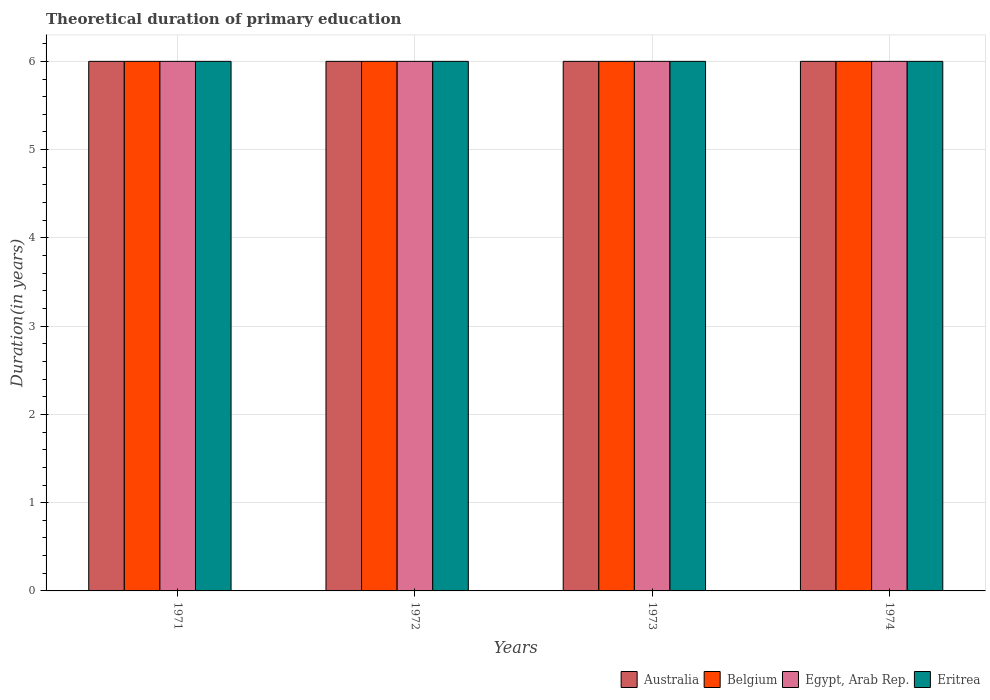Are the number of bars per tick equal to the number of legend labels?
Your answer should be compact. Yes. How many bars are there on the 1st tick from the left?
Offer a very short reply. 4. How many bars are there on the 4th tick from the right?
Keep it short and to the point. 4. In which year was the total theoretical duration of primary education in Belgium minimum?
Keep it short and to the point. 1971. What is the total total theoretical duration of primary education in Belgium in the graph?
Provide a short and direct response. 24. What is the difference between the total theoretical duration of primary education in Egypt, Arab Rep. in 1973 and the total theoretical duration of primary education in Eritrea in 1971?
Make the answer very short. 0. What is the average total theoretical duration of primary education in Eritrea per year?
Ensure brevity in your answer.  6. In the year 1972, what is the difference between the total theoretical duration of primary education in Eritrea and total theoretical duration of primary education in Belgium?
Ensure brevity in your answer.  0. Is the total theoretical duration of primary education in Egypt, Arab Rep. in 1971 less than that in 1972?
Provide a succinct answer. No. In how many years, is the total theoretical duration of primary education in Eritrea greater than the average total theoretical duration of primary education in Eritrea taken over all years?
Provide a short and direct response. 0. Is it the case that in every year, the sum of the total theoretical duration of primary education in Australia and total theoretical duration of primary education in Eritrea is greater than the sum of total theoretical duration of primary education in Egypt, Arab Rep. and total theoretical duration of primary education in Belgium?
Provide a succinct answer. No. What does the 4th bar from the left in 1973 represents?
Your response must be concise. Eritrea. What does the 2nd bar from the right in 1974 represents?
Your response must be concise. Egypt, Arab Rep. Is it the case that in every year, the sum of the total theoretical duration of primary education in Belgium and total theoretical duration of primary education in Eritrea is greater than the total theoretical duration of primary education in Australia?
Your response must be concise. Yes. What is the difference between two consecutive major ticks on the Y-axis?
Offer a terse response. 1. Does the graph contain any zero values?
Provide a succinct answer. No. How many legend labels are there?
Your response must be concise. 4. How are the legend labels stacked?
Your answer should be very brief. Horizontal. What is the title of the graph?
Ensure brevity in your answer.  Theoretical duration of primary education. Does "Macao" appear as one of the legend labels in the graph?
Make the answer very short. No. What is the label or title of the Y-axis?
Offer a terse response. Duration(in years). What is the Duration(in years) in Egypt, Arab Rep. in 1971?
Your answer should be compact. 6. What is the Duration(in years) of Eritrea in 1972?
Offer a terse response. 6. What is the Duration(in years) of Eritrea in 1973?
Keep it short and to the point. 6. What is the Duration(in years) of Australia in 1974?
Your answer should be compact. 6. What is the Duration(in years) of Belgium in 1974?
Give a very brief answer. 6. What is the Duration(in years) in Eritrea in 1974?
Ensure brevity in your answer.  6. Across all years, what is the maximum Duration(in years) of Australia?
Offer a very short reply. 6. Across all years, what is the maximum Duration(in years) in Belgium?
Make the answer very short. 6. Across all years, what is the maximum Duration(in years) of Eritrea?
Your response must be concise. 6. Across all years, what is the minimum Duration(in years) in Australia?
Your response must be concise. 6. Across all years, what is the minimum Duration(in years) of Belgium?
Provide a short and direct response. 6. Across all years, what is the minimum Duration(in years) of Eritrea?
Keep it short and to the point. 6. What is the total Duration(in years) in Australia in the graph?
Provide a short and direct response. 24. What is the difference between the Duration(in years) of Australia in 1971 and that in 1972?
Your answer should be very brief. 0. What is the difference between the Duration(in years) of Belgium in 1971 and that in 1972?
Provide a succinct answer. 0. What is the difference between the Duration(in years) of Eritrea in 1971 and that in 1972?
Offer a terse response. 0. What is the difference between the Duration(in years) of Australia in 1971 and that in 1973?
Offer a terse response. 0. What is the difference between the Duration(in years) in Egypt, Arab Rep. in 1971 and that in 1973?
Give a very brief answer. 0. What is the difference between the Duration(in years) in Australia in 1971 and that in 1974?
Your response must be concise. 0. What is the difference between the Duration(in years) in Australia in 1972 and that in 1973?
Give a very brief answer. 0. What is the difference between the Duration(in years) of Belgium in 1972 and that in 1974?
Offer a very short reply. 0. What is the difference between the Duration(in years) in Eritrea in 1972 and that in 1974?
Your answer should be very brief. 0. What is the difference between the Duration(in years) of Australia in 1973 and that in 1974?
Offer a terse response. 0. What is the difference between the Duration(in years) of Belgium in 1973 and that in 1974?
Ensure brevity in your answer.  0. What is the difference between the Duration(in years) of Australia in 1971 and the Duration(in years) of Eritrea in 1972?
Make the answer very short. 0. What is the difference between the Duration(in years) in Belgium in 1971 and the Duration(in years) in Egypt, Arab Rep. in 1972?
Offer a very short reply. 0. What is the difference between the Duration(in years) in Australia in 1971 and the Duration(in years) in Egypt, Arab Rep. in 1973?
Ensure brevity in your answer.  0. What is the difference between the Duration(in years) of Belgium in 1971 and the Duration(in years) of Eritrea in 1973?
Ensure brevity in your answer.  0. What is the difference between the Duration(in years) of Egypt, Arab Rep. in 1971 and the Duration(in years) of Eritrea in 1973?
Offer a very short reply. 0. What is the difference between the Duration(in years) in Australia in 1971 and the Duration(in years) in Belgium in 1974?
Keep it short and to the point. 0. What is the difference between the Duration(in years) of Egypt, Arab Rep. in 1971 and the Duration(in years) of Eritrea in 1974?
Ensure brevity in your answer.  0. What is the difference between the Duration(in years) of Australia in 1972 and the Duration(in years) of Belgium in 1973?
Give a very brief answer. 0. What is the difference between the Duration(in years) of Australia in 1972 and the Duration(in years) of Eritrea in 1973?
Provide a succinct answer. 0. What is the difference between the Duration(in years) in Belgium in 1972 and the Duration(in years) in Egypt, Arab Rep. in 1973?
Make the answer very short. 0. What is the difference between the Duration(in years) in Belgium in 1972 and the Duration(in years) in Eritrea in 1973?
Your response must be concise. 0. What is the difference between the Duration(in years) in Egypt, Arab Rep. in 1972 and the Duration(in years) in Eritrea in 1973?
Provide a succinct answer. 0. What is the difference between the Duration(in years) in Belgium in 1972 and the Duration(in years) in Egypt, Arab Rep. in 1974?
Provide a short and direct response. 0. What is the difference between the Duration(in years) in Belgium in 1972 and the Duration(in years) in Eritrea in 1974?
Give a very brief answer. 0. What is the difference between the Duration(in years) in Egypt, Arab Rep. in 1972 and the Duration(in years) in Eritrea in 1974?
Offer a terse response. 0. What is the difference between the Duration(in years) in Belgium in 1973 and the Duration(in years) in Egypt, Arab Rep. in 1974?
Give a very brief answer. 0. What is the difference between the Duration(in years) in Belgium in 1973 and the Duration(in years) in Eritrea in 1974?
Keep it short and to the point. 0. What is the average Duration(in years) of Belgium per year?
Make the answer very short. 6. In the year 1971, what is the difference between the Duration(in years) of Australia and Duration(in years) of Belgium?
Offer a terse response. 0. In the year 1971, what is the difference between the Duration(in years) in Australia and Duration(in years) in Egypt, Arab Rep.?
Ensure brevity in your answer.  0. In the year 1971, what is the difference between the Duration(in years) in Australia and Duration(in years) in Eritrea?
Keep it short and to the point. 0. In the year 1972, what is the difference between the Duration(in years) of Australia and Duration(in years) of Egypt, Arab Rep.?
Ensure brevity in your answer.  0. In the year 1972, what is the difference between the Duration(in years) of Australia and Duration(in years) of Eritrea?
Provide a succinct answer. 0. In the year 1972, what is the difference between the Duration(in years) of Egypt, Arab Rep. and Duration(in years) of Eritrea?
Offer a very short reply. 0. In the year 1973, what is the difference between the Duration(in years) in Australia and Duration(in years) in Belgium?
Your response must be concise. 0. In the year 1973, what is the difference between the Duration(in years) of Australia and Duration(in years) of Egypt, Arab Rep.?
Your answer should be very brief. 0. In the year 1973, what is the difference between the Duration(in years) of Australia and Duration(in years) of Eritrea?
Give a very brief answer. 0. In the year 1973, what is the difference between the Duration(in years) in Belgium and Duration(in years) in Eritrea?
Make the answer very short. 0. In the year 1973, what is the difference between the Duration(in years) of Egypt, Arab Rep. and Duration(in years) of Eritrea?
Give a very brief answer. 0. What is the ratio of the Duration(in years) in Australia in 1971 to that in 1972?
Ensure brevity in your answer.  1. What is the ratio of the Duration(in years) of Egypt, Arab Rep. in 1971 to that in 1972?
Your answer should be very brief. 1. What is the ratio of the Duration(in years) in Eritrea in 1971 to that in 1973?
Keep it short and to the point. 1. What is the ratio of the Duration(in years) in Belgium in 1971 to that in 1974?
Give a very brief answer. 1. What is the ratio of the Duration(in years) in Egypt, Arab Rep. in 1971 to that in 1974?
Ensure brevity in your answer.  1. What is the ratio of the Duration(in years) in Eritrea in 1972 to that in 1973?
Offer a very short reply. 1. What is the ratio of the Duration(in years) in Australia in 1972 to that in 1974?
Provide a short and direct response. 1. What is the ratio of the Duration(in years) of Belgium in 1972 to that in 1974?
Ensure brevity in your answer.  1. What is the ratio of the Duration(in years) of Egypt, Arab Rep. in 1972 to that in 1974?
Your answer should be compact. 1. What is the ratio of the Duration(in years) of Eritrea in 1972 to that in 1974?
Provide a short and direct response. 1. What is the ratio of the Duration(in years) of Egypt, Arab Rep. in 1973 to that in 1974?
Give a very brief answer. 1. What is the difference between the highest and the second highest Duration(in years) in Egypt, Arab Rep.?
Your answer should be compact. 0. What is the difference between the highest and the second highest Duration(in years) in Eritrea?
Ensure brevity in your answer.  0. What is the difference between the highest and the lowest Duration(in years) of Australia?
Provide a succinct answer. 0. What is the difference between the highest and the lowest Duration(in years) of Belgium?
Provide a short and direct response. 0. 